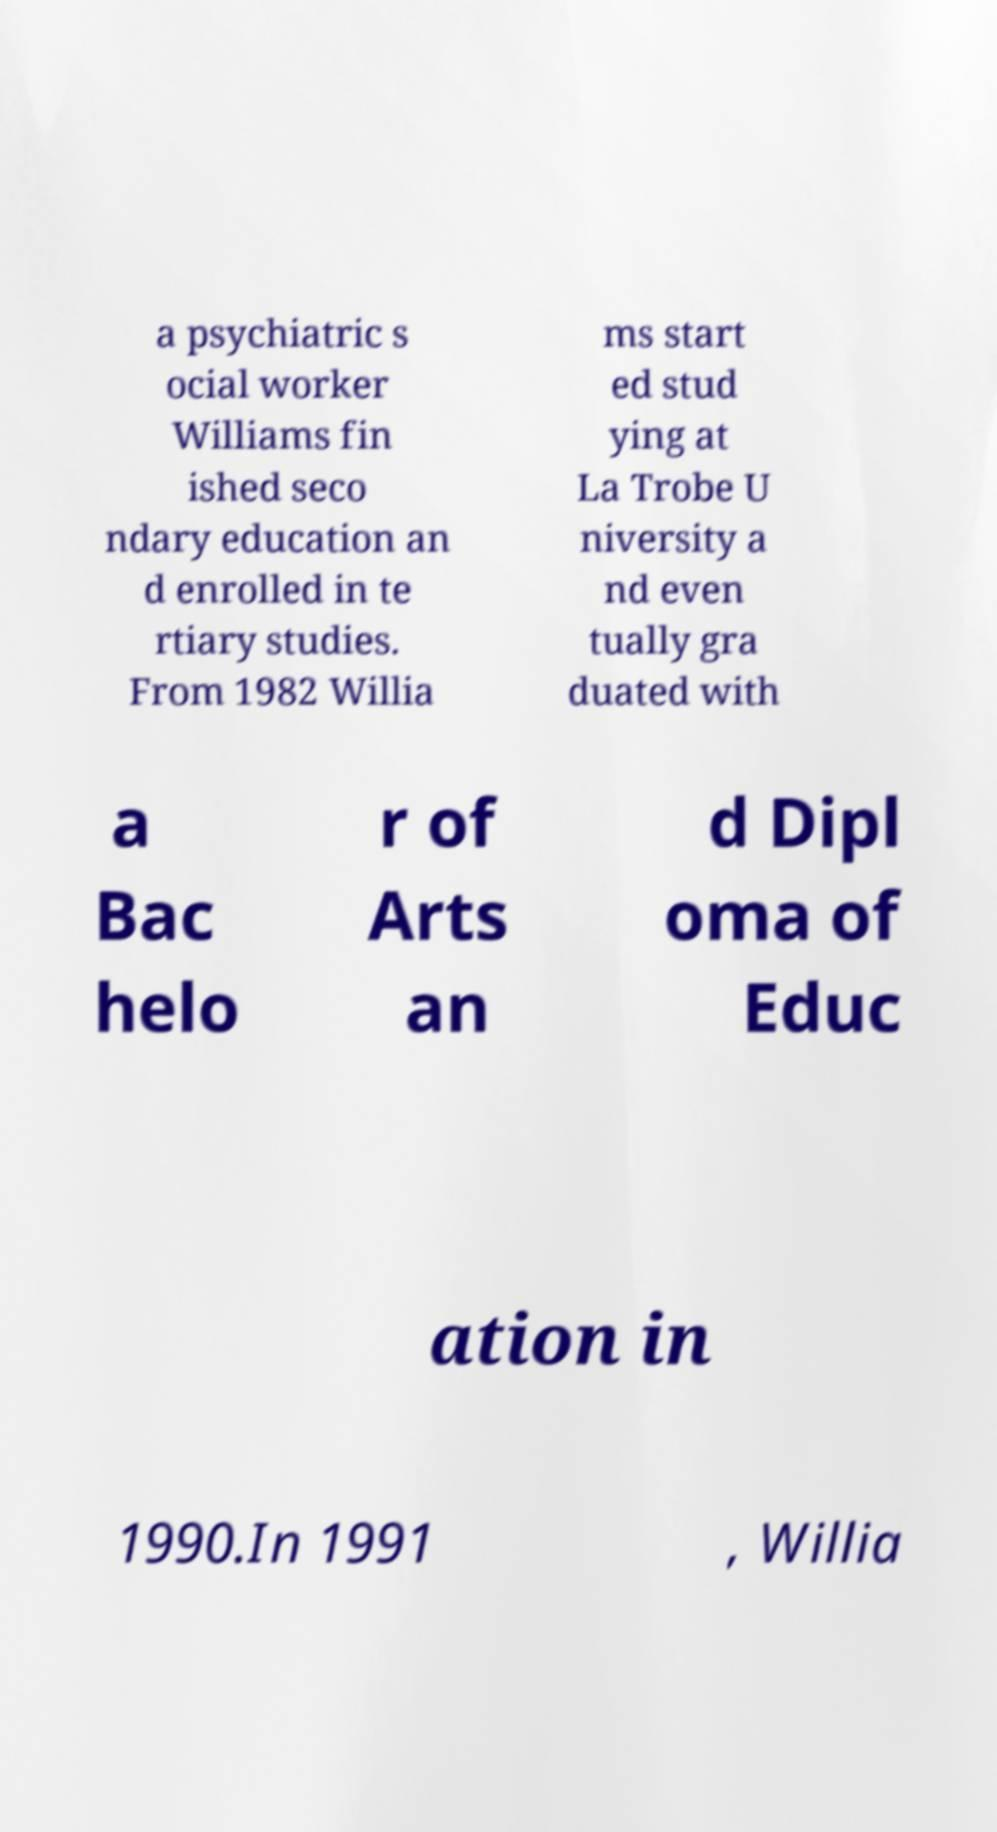Please read and relay the text visible in this image. What does it say? a psychiatric s ocial worker Williams fin ished seco ndary education an d enrolled in te rtiary studies. From 1982 Willia ms start ed stud ying at La Trobe U niversity a nd even tually gra duated with a Bac helo r of Arts an d Dipl oma of Educ ation in 1990.In 1991 , Willia 